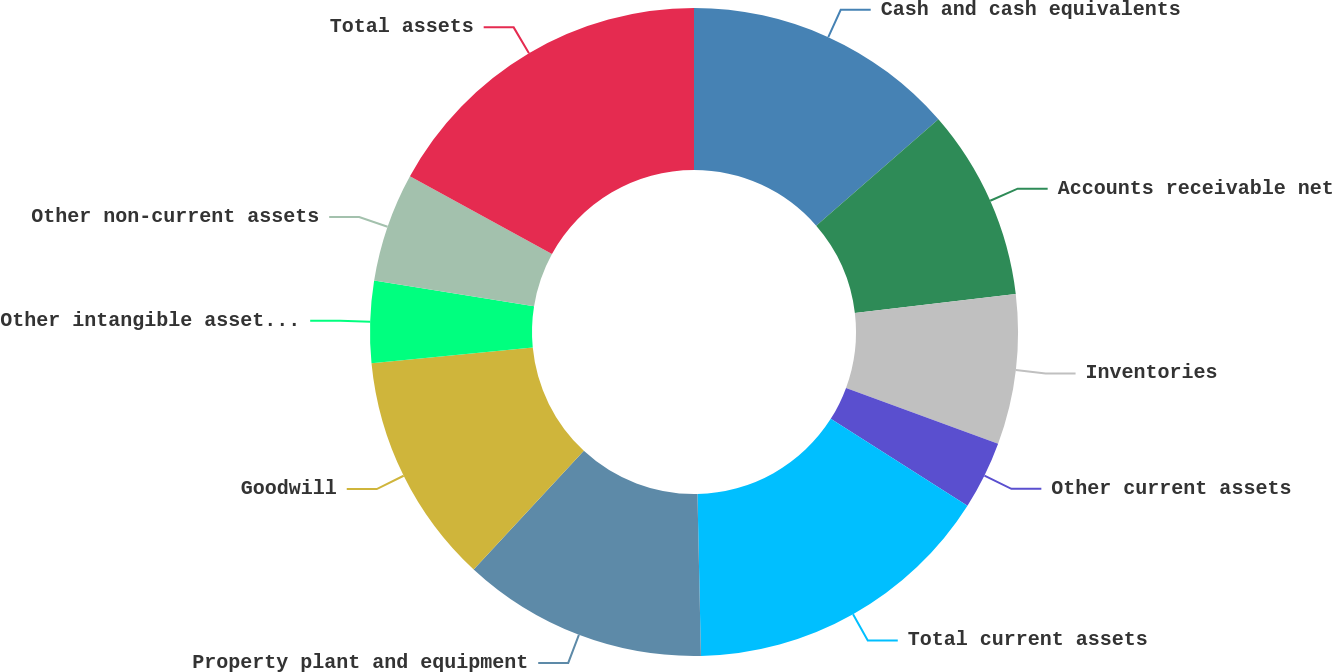Convert chart to OTSL. <chart><loc_0><loc_0><loc_500><loc_500><pie_chart><fcel>Cash and cash equivalents<fcel>Accounts receivable net<fcel>Inventories<fcel>Other current assets<fcel>Total current assets<fcel>Property plant and equipment<fcel>Goodwill<fcel>Other intangible assets net<fcel>Other non-current assets<fcel>Total assets<nl><fcel>13.6%<fcel>9.52%<fcel>7.48%<fcel>3.4%<fcel>15.65%<fcel>12.24%<fcel>11.56%<fcel>4.08%<fcel>5.44%<fcel>17.01%<nl></chart> 